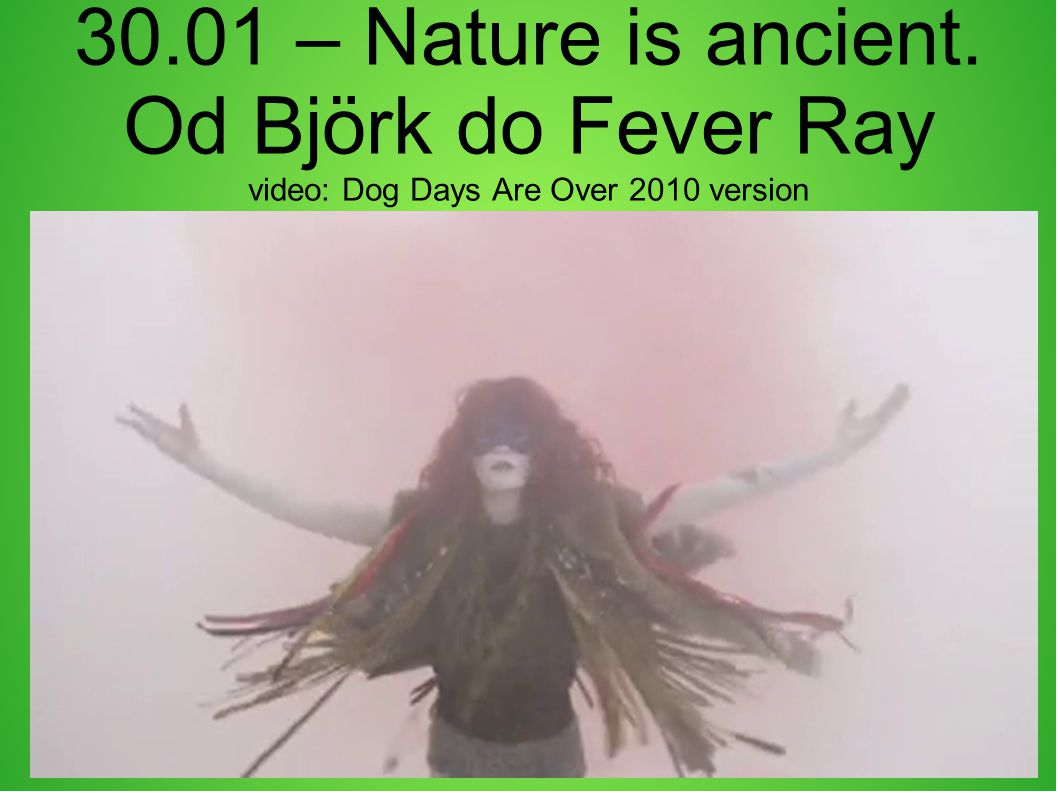How does the text 'Nature is ancient' relate to the visual elements? The text 'Nature is ancient' underscores the timeless and primordial essence of the visual elements. The figure’s attire, which seems to incorporate natural elements like feathers and earthy colors, may represent a deep connection to ancient rituals or traditions. This theme of reconnecting with the past, especially nature, is visually echoed through the mystical ambiance of the smoke and the figure’s grounded yet ethereal presence.  If this image were part of a fantasy story, describe a brief scene where it appears. In a fantasy story, this image could appear during a pivotal scene where the protagonist meets a mythical figure in the heart of an ancient forest. The air is thick with a magical mist, and as the protagonist approaches, the figure emerges with arms extended, welcoming them into a realm of forgotten legends. The figure speaks of a prophecy, which foretells the protagonist's crucial role in restoring balance to their world, and the fog swirls, revealing glimpses of the trials that lie ahead. 